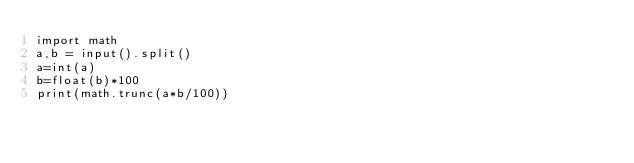<code> <loc_0><loc_0><loc_500><loc_500><_Python_>import math
a,b = input().split()
a=int(a)
b=float(b)*100
print(math.trunc(a*b/100))</code> 